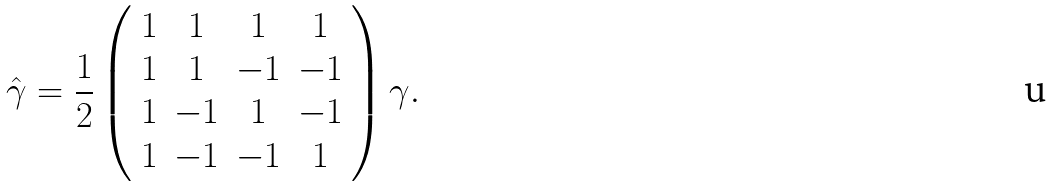<formula> <loc_0><loc_0><loc_500><loc_500>\hat { \gamma } = \frac { 1 } { 2 } \left ( \begin{array} { c c c c } 1 & 1 & 1 & 1 \\ 1 & 1 & - 1 & - 1 \\ 1 & - 1 & 1 & - 1 \\ 1 & - 1 & - 1 & 1 \end{array} \right ) \gamma .</formula> 